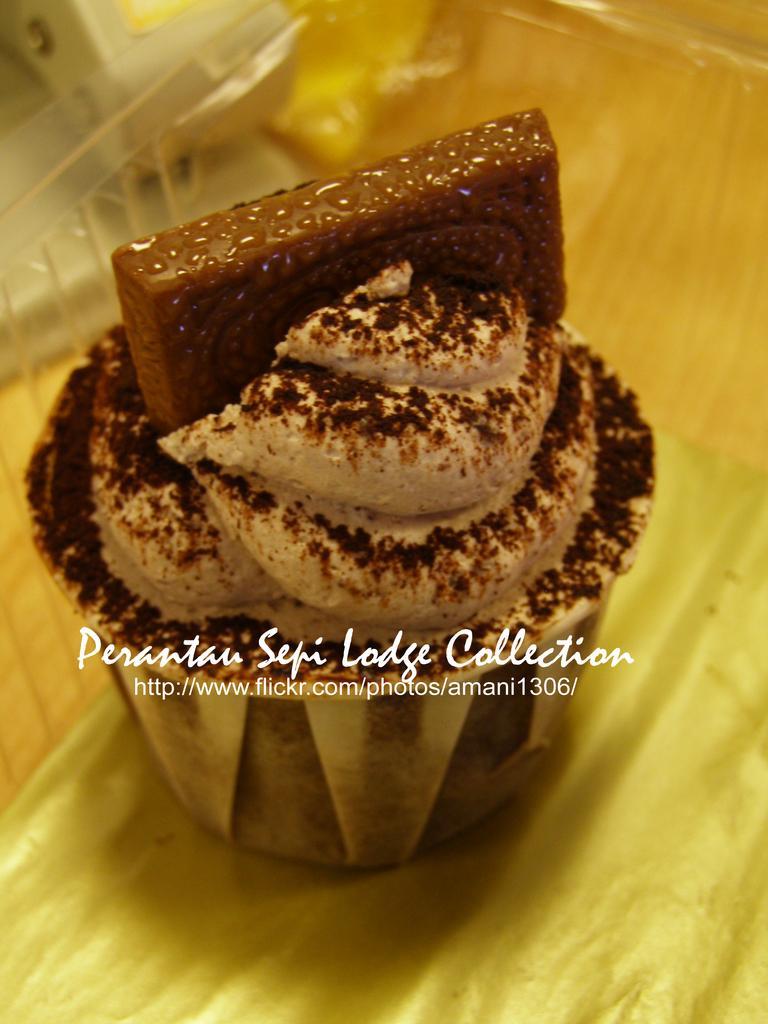Please provide a concise description of this image. Here we can see a pastry in a box and this is a watermark. 